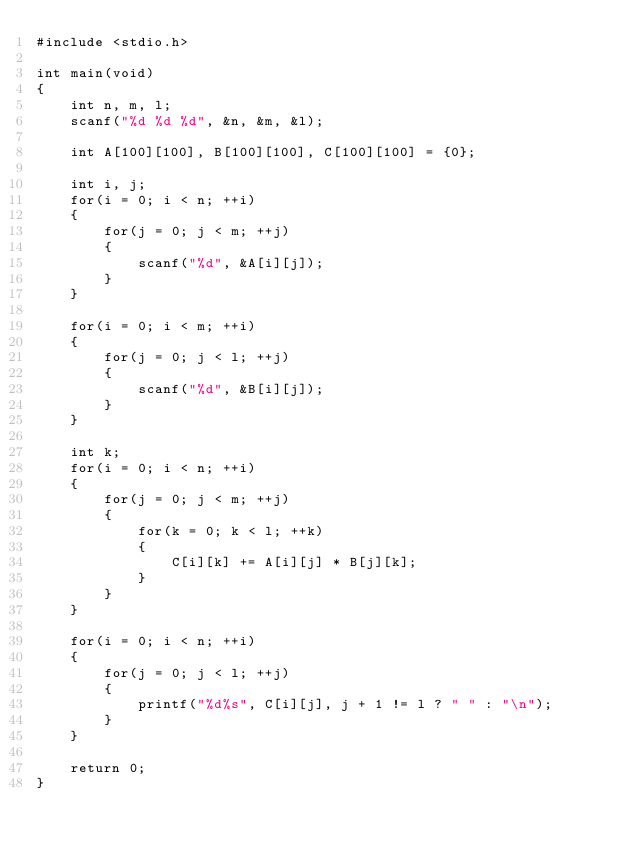<code> <loc_0><loc_0><loc_500><loc_500><_C_>#include <stdio.h>

int main(void)
{
    int n, m, l;
    scanf("%d %d %d", &n, &m, &l);

    int A[100][100], B[100][100], C[100][100] = {0};

    int i, j;
    for(i = 0; i < n; ++i)
    {
        for(j = 0; j < m; ++j)
        {
            scanf("%d", &A[i][j]);
        }
    }

    for(i = 0; i < m; ++i)
    {
        for(j = 0; j < l; ++j)
        {
            scanf("%d", &B[i][j]);
        }
    }

    int k;
    for(i = 0; i < n; ++i)
    {
        for(j = 0; j < m; ++j)
        {
            for(k = 0; k < l; ++k)
            {
                C[i][k] += A[i][j] * B[j][k];
            }
        }
    }

    for(i = 0; i < n; ++i)
    {
        for(j = 0; j < l; ++j)
        {
            printf("%d%s", C[i][j], j + 1 != l ? " " : "\n");
        }
    }

    return 0;
}</code> 